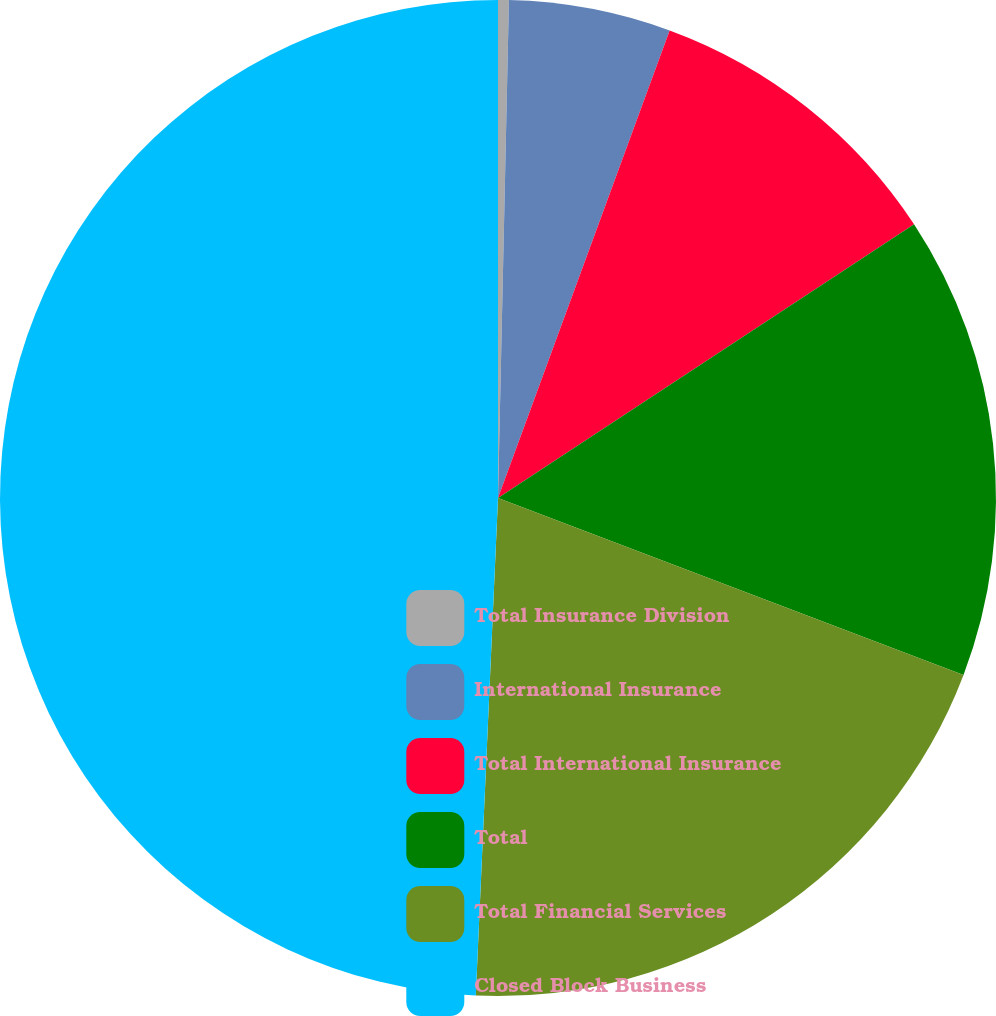Convert chart to OTSL. <chart><loc_0><loc_0><loc_500><loc_500><pie_chart><fcel>Total Insurance Division<fcel>International Insurance<fcel>Total International Insurance<fcel>Total<fcel>Total Financial Services<fcel>Closed Block Business<nl><fcel>0.35%<fcel>5.25%<fcel>10.14%<fcel>15.04%<fcel>19.93%<fcel>49.29%<nl></chart> 